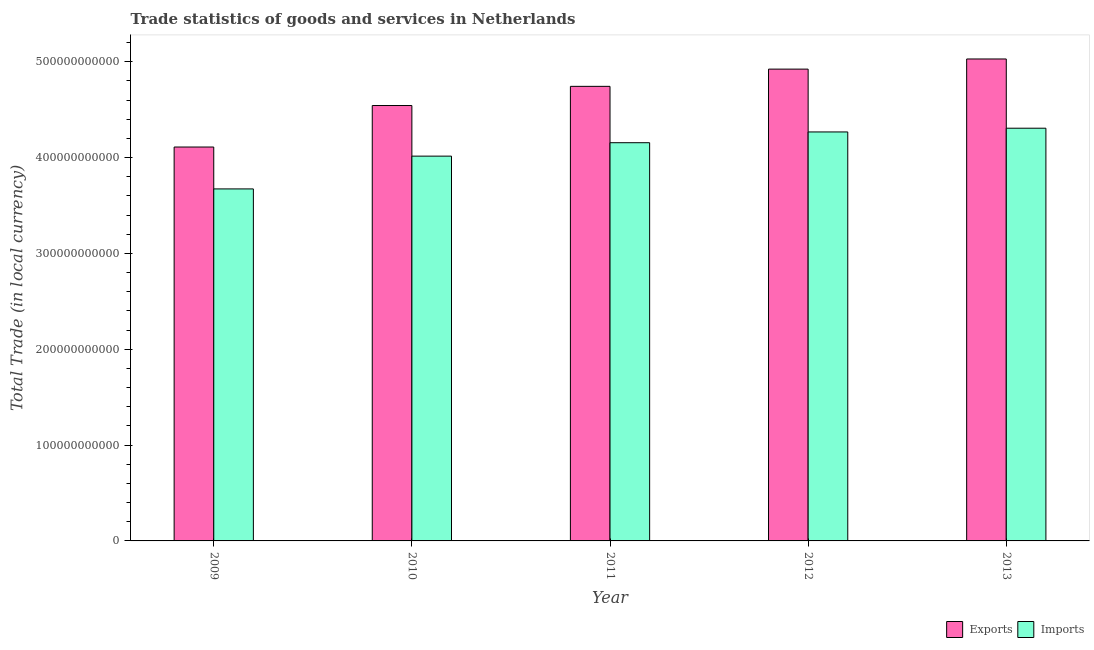How many groups of bars are there?
Your response must be concise. 5. Are the number of bars on each tick of the X-axis equal?
Make the answer very short. Yes. What is the label of the 3rd group of bars from the left?
Offer a very short reply. 2011. In how many cases, is the number of bars for a given year not equal to the number of legend labels?
Your response must be concise. 0. What is the export of goods and services in 2011?
Keep it short and to the point. 4.74e+11. Across all years, what is the maximum export of goods and services?
Your answer should be very brief. 5.03e+11. Across all years, what is the minimum imports of goods and services?
Provide a short and direct response. 3.67e+11. In which year was the imports of goods and services maximum?
Give a very brief answer. 2013. What is the total export of goods and services in the graph?
Make the answer very short. 2.34e+12. What is the difference between the export of goods and services in 2012 and that in 2013?
Your answer should be very brief. -1.06e+1. What is the difference between the export of goods and services in 2010 and the imports of goods and services in 2013?
Offer a very short reply. -4.86e+1. What is the average export of goods and services per year?
Offer a very short reply. 4.67e+11. In the year 2013, what is the difference between the export of goods and services and imports of goods and services?
Provide a short and direct response. 0. What is the ratio of the imports of goods and services in 2011 to that in 2013?
Make the answer very short. 0.96. What is the difference between the highest and the second highest export of goods and services?
Provide a short and direct response. 1.06e+1. What is the difference between the highest and the lowest imports of goods and services?
Offer a terse response. 6.34e+1. In how many years, is the export of goods and services greater than the average export of goods and services taken over all years?
Your response must be concise. 3. Is the sum of the export of goods and services in 2011 and 2013 greater than the maximum imports of goods and services across all years?
Your answer should be very brief. Yes. What does the 1st bar from the left in 2009 represents?
Your answer should be very brief. Exports. What does the 2nd bar from the right in 2012 represents?
Provide a succinct answer. Exports. How many bars are there?
Offer a terse response. 10. How many years are there in the graph?
Offer a terse response. 5. What is the difference between two consecutive major ticks on the Y-axis?
Provide a short and direct response. 1.00e+11. Does the graph contain any zero values?
Your answer should be compact. No. Does the graph contain grids?
Make the answer very short. No. How many legend labels are there?
Your answer should be compact. 2. What is the title of the graph?
Provide a succinct answer. Trade statistics of goods and services in Netherlands. What is the label or title of the Y-axis?
Make the answer very short. Total Trade (in local currency). What is the Total Trade (in local currency) in Exports in 2009?
Provide a short and direct response. 4.11e+11. What is the Total Trade (in local currency) of Imports in 2009?
Offer a very short reply. 3.67e+11. What is the Total Trade (in local currency) in Exports in 2010?
Your response must be concise. 4.54e+11. What is the Total Trade (in local currency) of Imports in 2010?
Provide a succinct answer. 4.02e+11. What is the Total Trade (in local currency) in Exports in 2011?
Provide a short and direct response. 4.74e+11. What is the Total Trade (in local currency) in Imports in 2011?
Make the answer very short. 4.16e+11. What is the Total Trade (in local currency) of Exports in 2012?
Provide a succinct answer. 4.92e+11. What is the Total Trade (in local currency) of Imports in 2012?
Make the answer very short. 4.27e+11. What is the Total Trade (in local currency) of Exports in 2013?
Provide a short and direct response. 5.03e+11. What is the Total Trade (in local currency) in Imports in 2013?
Make the answer very short. 4.31e+11. Across all years, what is the maximum Total Trade (in local currency) in Exports?
Make the answer very short. 5.03e+11. Across all years, what is the maximum Total Trade (in local currency) of Imports?
Provide a succinct answer. 4.31e+11. Across all years, what is the minimum Total Trade (in local currency) in Exports?
Give a very brief answer. 4.11e+11. Across all years, what is the minimum Total Trade (in local currency) of Imports?
Give a very brief answer. 3.67e+11. What is the total Total Trade (in local currency) in Exports in the graph?
Your answer should be very brief. 2.34e+12. What is the total Total Trade (in local currency) in Imports in the graph?
Give a very brief answer. 2.04e+12. What is the difference between the Total Trade (in local currency) of Exports in 2009 and that in 2010?
Ensure brevity in your answer.  -4.33e+1. What is the difference between the Total Trade (in local currency) in Imports in 2009 and that in 2010?
Offer a very short reply. -3.42e+1. What is the difference between the Total Trade (in local currency) of Exports in 2009 and that in 2011?
Give a very brief answer. -6.33e+1. What is the difference between the Total Trade (in local currency) of Imports in 2009 and that in 2011?
Provide a succinct answer. -4.82e+1. What is the difference between the Total Trade (in local currency) of Exports in 2009 and that in 2012?
Ensure brevity in your answer.  -8.13e+1. What is the difference between the Total Trade (in local currency) of Imports in 2009 and that in 2012?
Provide a short and direct response. -5.95e+1. What is the difference between the Total Trade (in local currency) of Exports in 2009 and that in 2013?
Your answer should be very brief. -9.19e+1. What is the difference between the Total Trade (in local currency) in Imports in 2009 and that in 2013?
Your response must be concise. -6.34e+1. What is the difference between the Total Trade (in local currency) of Exports in 2010 and that in 2011?
Give a very brief answer. -2.00e+1. What is the difference between the Total Trade (in local currency) in Imports in 2010 and that in 2011?
Provide a succinct answer. -1.40e+1. What is the difference between the Total Trade (in local currency) of Exports in 2010 and that in 2012?
Your answer should be compact. -3.80e+1. What is the difference between the Total Trade (in local currency) of Imports in 2010 and that in 2012?
Make the answer very short. -2.53e+1. What is the difference between the Total Trade (in local currency) of Exports in 2010 and that in 2013?
Make the answer very short. -4.86e+1. What is the difference between the Total Trade (in local currency) in Imports in 2010 and that in 2013?
Ensure brevity in your answer.  -2.91e+1. What is the difference between the Total Trade (in local currency) of Exports in 2011 and that in 2012?
Keep it short and to the point. -1.80e+1. What is the difference between the Total Trade (in local currency) of Imports in 2011 and that in 2012?
Your response must be concise. -1.12e+1. What is the difference between the Total Trade (in local currency) of Exports in 2011 and that in 2013?
Ensure brevity in your answer.  -2.86e+1. What is the difference between the Total Trade (in local currency) in Imports in 2011 and that in 2013?
Provide a succinct answer. -1.51e+1. What is the difference between the Total Trade (in local currency) of Exports in 2012 and that in 2013?
Your answer should be very brief. -1.06e+1. What is the difference between the Total Trade (in local currency) of Imports in 2012 and that in 2013?
Ensure brevity in your answer.  -3.88e+09. What is the difference between the Total Trade (in local currency) in Exports in 2009 and the Total Trade (in local currency) in Imports in 2010?
Offer a terse response. 9.50e+09. What is the difference between the Total Trade (in local currency) of Exports in 2009 and the Total Trade (in local currency) of Imports in 2011?
Provide a succinct answer. -4.51e+09. What is the difference between the Total Trade (in local currency) of Exports in 2009 and the Total Trade (in local currency) of Imports in 2012?
Your answer should be very brief. -1.57e+1. What is the difference between the Total Trade (in local currency) in Exports in 2009 and the Total Trade (in local currency) in Imports in 2013?
Offer a very short reply. -1.96e+1. What is the difference between the Total Trade (in local currency) in Exports in 2010 and the Total Trade (in local currency) in Imports in 2011?
Your answer should be compact. 3.88e+1. What is the difference between the Total Trade (in local currency) of Exports in 2010 and the Total Trade (in local currency) of Imports in 2012?
Your answer should be compact. 2.76e+1. What is the difference between the Total Trade (in local currency) of Exports in 2010 and the Total Trade (in local currency) of Imports in 2013?
Your answer should be very brief. 2.37e+1. What is the difference between the Total Trade (in local currency) of Exports in 2011 and the Total Trade (in local currency) of Imports in 2012?
Provide a succinct answer. 4.76e+1. What is the difference between the Total Trade (in local currency) in Exports in 2011 and the Total Trade (in local currency) in Imports in 2013?
Keep it short and to the point. 4.37e+1. What is the difference between the Total Trade (in local currency) of Exports in 2012 and the Total Trade (in local currency) of Imports in 2013?
Your response must be concise. 6.17e+1. What is the average Total Trade (in local currency) of Exports per year?
Ensure brevity in your answer.  4.67e+11. What is the average Total Trade (in local currency) of Imports per year?
Offer a terse response. 4.08e+11. In the year 2009, what is the difference between the Total Trade (in local currency) of Exports and Total Trade (in local currency) of Imports?
Your answer should be compact. 4.37e+1. In the year 2010, what is the difference between the Total Trade (in local currency) of Exports and Total Trade (in local currency) of Imports?
Make the answer very short. 5.28e+1. In the year 2011, what is the difference between the Total Trade (in local currency) of Exports and Total Trade (in local currency) of Imports?
Provide a short and direct response. 5.88e+1. In the year 2012, what is the difference between the Total Trade (in local currency) in Exports and Total Trade (in local currency) in Imports?
Make the answer very short. 6.56e+1. In the year 2013, what is the difference between the Total Trade (in local currency) in Exports and Total Trade (in local currency) in Imports?
Make the answer very short. 7.23e+1. What is the ratio of the Total Trade (in local currency) of Exports in 2009 to that in 2010?
Give a very brief answer. 0.9. What is the ratio of the Total Trade (in local currency) in Imports in 2009 to that in 2010?
Your answer should be compact. 0.91. What is the ratio of the Total Trade (in local currency) of Exports in 2009 to that in 2011?
Your answer should be very brief. 0.87. What is the ratio of the Total Trade (in local currency) in Imports in 2009 to that in 2011?
Make the answer very short. 0.88. What is the ratio of the Total Trade (in local currency) of Exports in 2009 to that in 2012?
Your response must be concise. 0.83. What is the ratio of the Total Trade (in local currency) in Imports in 2009 to that in 2012?
Offer a very short reply. 0.86. What is the ratio of the Total Trade (in local currency) of Exports in 2009 to that in 2013?
Give a very brief answer. 0.82. What is the ratio of the Total Trade (in local currency) in Imports in 2009 to that in 2013?
Make the answer very short. 0.85. What is the ratio of the Total Trade (in local currency) of Exports in 2010 to that in 2011?
Offer a terse response. 0.96. What is the ratio of the Total Trade (in local currency) in Imports in 2010 to that in 2011?
Ensure brevity in your answer.  0.97. What is the ratio of the Total Trade (in local currency) in Exports in 2010 to that in 2012?
Offer a terse response. 0.92. What is the ratio of the Total Trade (in local currency) of Imports in 2010 to that in 2012?
Keep it short and to the point. 0.94. What is the ratio of the Total Trade (in local currency) in Exports in 2010 to that in 2013?
Provide a succinct answer. 0.9. What is the ratio of the Total Trade (in local currency) in Imports in 2010 to that in 2013?
Keep it short and to the point. 0.93. What is the ratio of the Total Trade (in local currency) of Exports in 2011 to that in 2012?
Offer a very short reply. 0.96. What is the ratio of the Total Trade (in local currency) in Imports in 2011 to that in 2012?
Provide a succinct answer. 0.97. What is the ratio of the Total Trade (in local currency) in Exports in 2011 to that in 2013?
Provide a short and direct response. 0.94. What is the ratio of the Total Trade (in local currency) of Imports in 2011 to that in 2013?
Your answer should be compact. 0.96. What is the ratio of the Total Trade (in local currency) of Imports in 2012 to that in 2013?
Give a very brief answer. 0.99. What is the difference between the highest and the second highest Total Trade (in local currency) of Exports?
Make the answer very short. 1.06e+1. What is the difference between the highest and the second highest Total Trade (in local currency) of Imports?
Provide a short and direct response. 3.88e+09. What is the difference between the highest and the lowest Total Trade (in local currency) in Exports?
Provide a short and direct response. 9.19e+1. What is the difference between the highest and the lowest Total Trade (in local currency) of Imports?
Ensure brevity in your answer.  6.34e+1. 